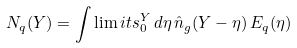<formula> <loc_0><loc_0><loc_500><loc_500>N _ { q } ( Y ) = \int \lim i t s _ { 0 } ^ { Y } \, d \eta \, \hat { n } _ { g } ( Y - \eta ) \, E _ { q } ( \eta ) \,</formula> 